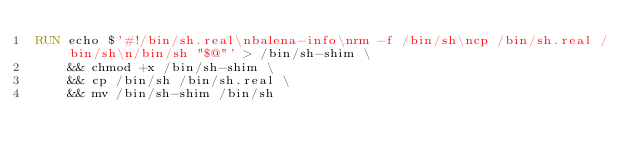<code> <loc_0><loc_0><loc_500><loc_500><_Dockerfile_>RUN echo $'#!/bin/sh.real\nbalena-info\nrm -f /bin/sh\ncp /bin/sh.real /bin/sh\n/bin/sh "$@"' > /bin/sh-shim \
	&& chmod +x /bin/sh-shim \
	&& cp /bin/sh /bin/sh.real \
	&& mv /bin/sh-shim /bin/sh</code> 